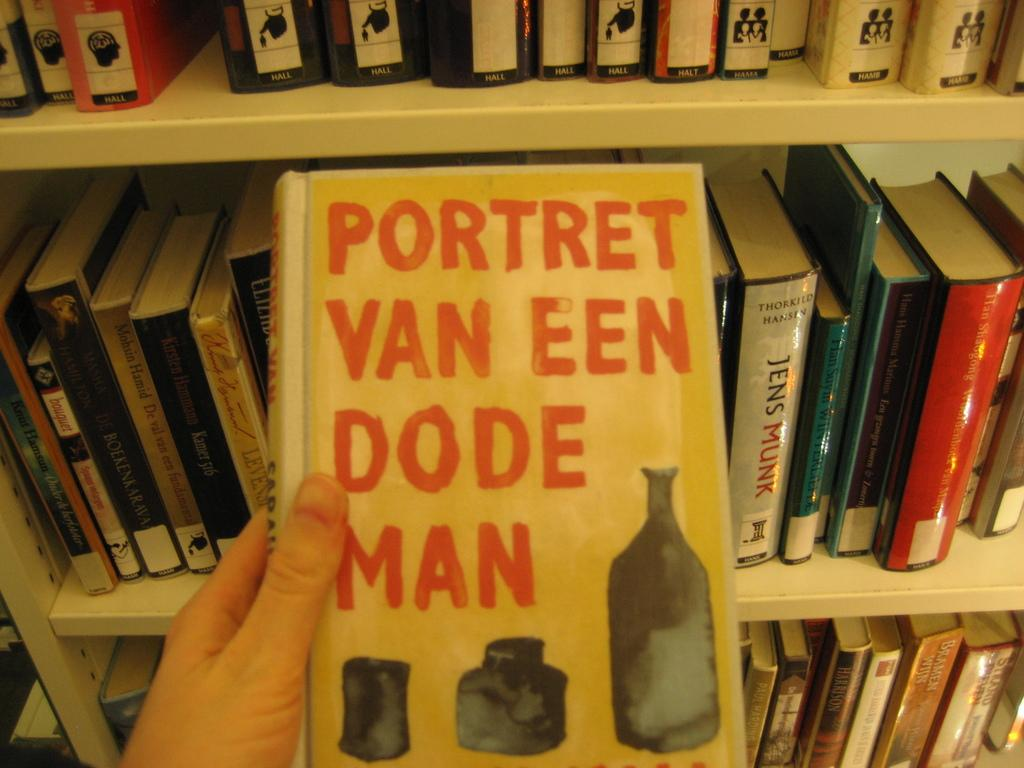<image>
Create a compact narrative representing the image presented. A book titled Portret Van Een Dode Man is being held up in a library 